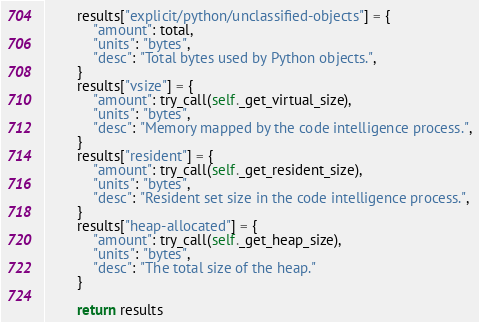<code> <loc_0><loc_0><loc_500><loc_500><_Python_>
        results["explicit/python/unclassified-objects"] = {
            "amount": total,
            "units": "bytes",
            "desc": "Total bytes used by Python objects.",
        }
        results["vsize"] = {
            "amount": try_call(self._get_virtual_size),
            "units": "bytes",
            "desc": "Memory mapped by the code intelligence process.",
        }
        results["resident"] = {
            "amount": try_call(self._get_resident_size),
            "units": "bytes",
            "desc": "Resident set size in the code intelligence process.",
        }
        results["heap-allocated"] = {
            "amount": try_call(self._get_heap_size),
            "units": "bytes",
            "desc": "The total size of the heap."
        }

        return results
</code> 